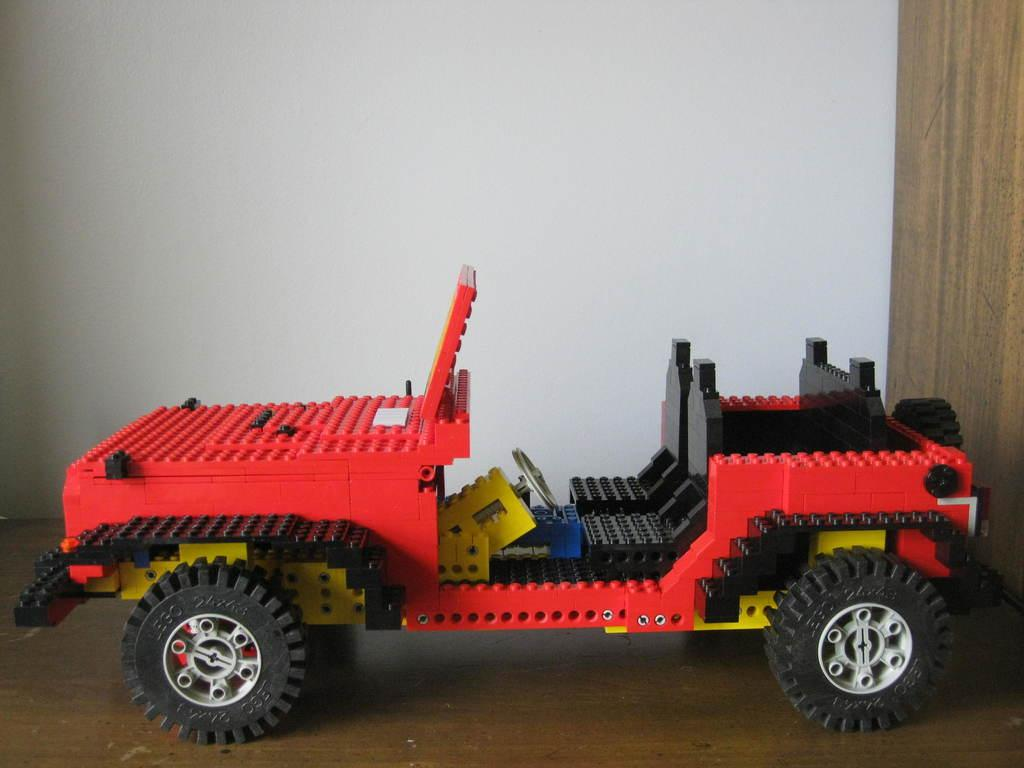What type of toy is present in the image? There is a toy vehicle in the image. What material is the toy vehicle made of? The toy vehicle is made up of lego. What is the color of the surface on which the toy vehicle is placed? The toy vehicle is on a brown colored surface. What can be seen in the background of the image? There is a white colored wall in the background of the image. How many cats are sitting on the toy vehicle in the image? There are no cats present in the image; it only features a toy vehicle made of lego on a brown surface with a white wall in the background. 